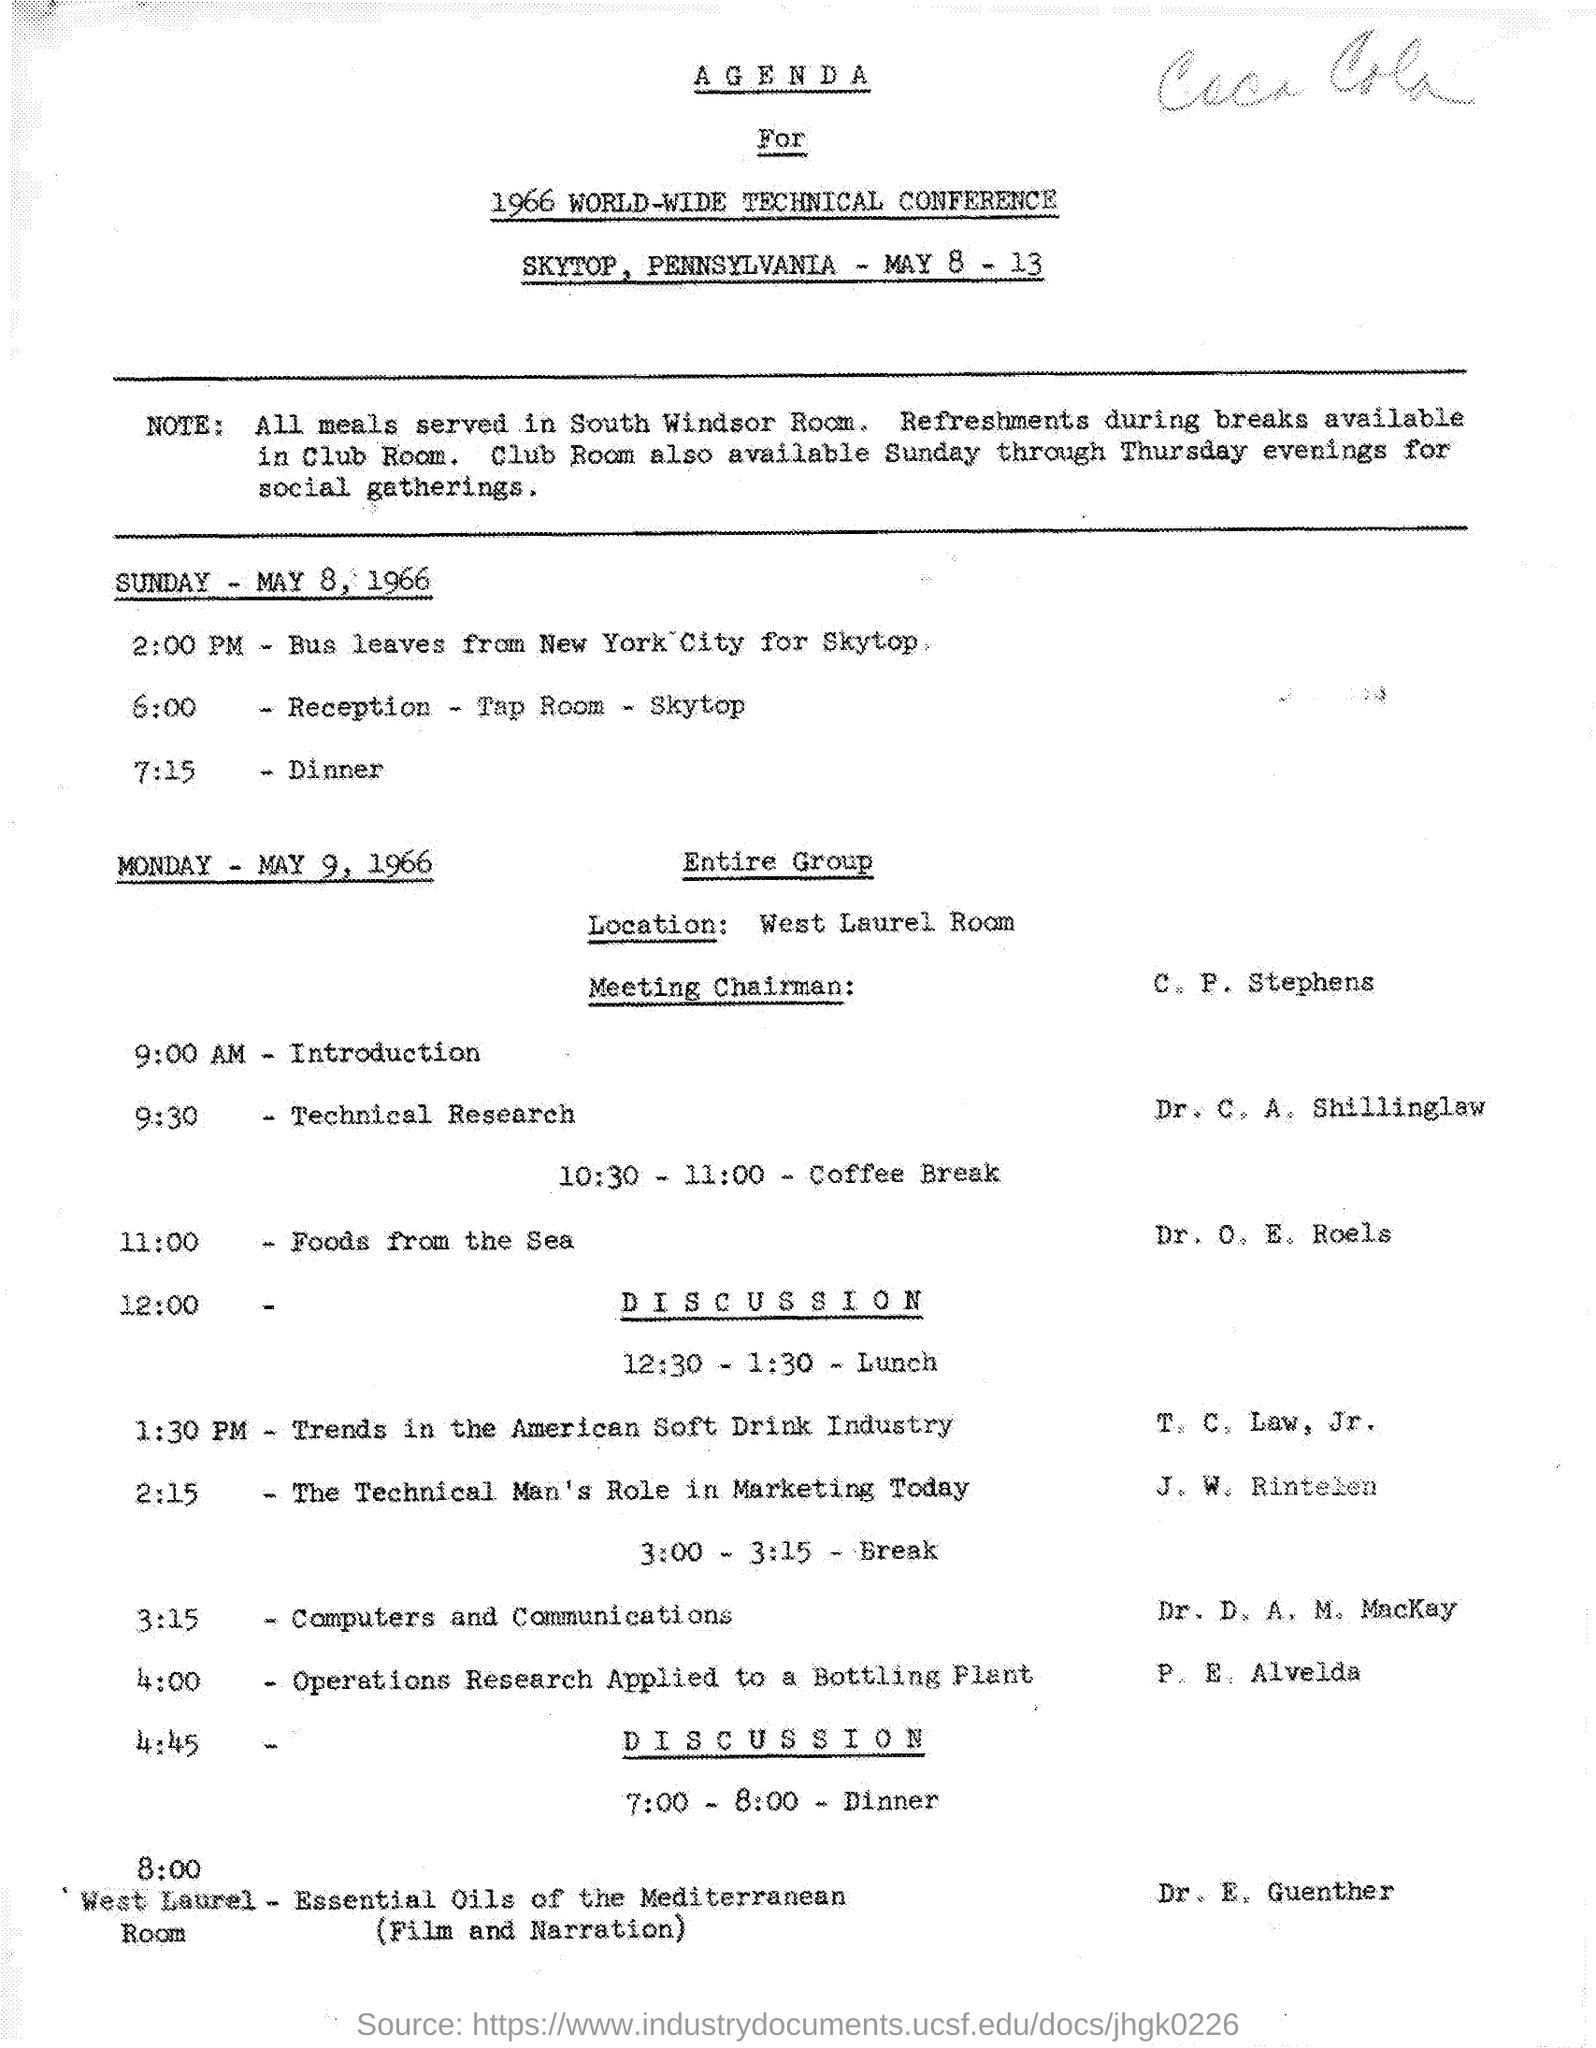Where are all meals served?
Keep it short and to the point. South windsor room. When is the dinner on Sunday - May 8, 1966?
Your answer should be compact. 7:15. When is the Introduction?
Provide a succinct answer. 9:00 AM. When is the Coffee Break?
Ensure brevity in your answer.  10:30 - 11:00. 